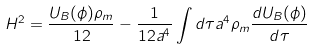Convert formula to latex. <formula><loc_0><loc_0><loc_500><loc_500>H ^ { 2 } = \frac { U _ { B } ( \phi ) \rho _ { m } } { 1 2 } - \frac { 1 } { 1 2 a ^ { 4 } } \int d \tau a ^ { 4 } \rho _ { m } \frac { d U _ { B } ( \phi ) } { d \tau }</formula> 